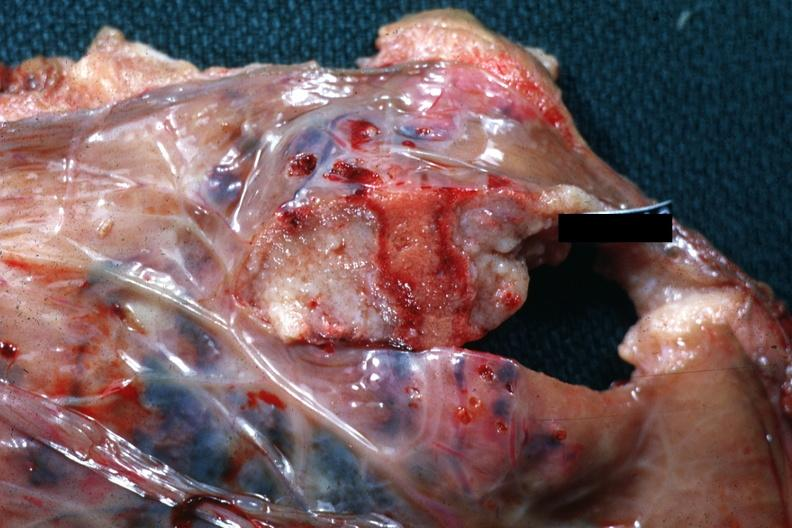s placenta present?
Answer the question using a single word or phrase. Yes 